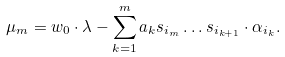<formula> <loc_0><loc_0><loc_500><loc_500>\mu _ { m } = w _ { 0 } \cdot \lambda - \sum _ { k = 1 } ^ { m } a _ { k } s _ { i _ { m } } \dots s _ { i _ { k + 1 } } \cdot \alpha _ { i _ { k } } .</formula> 